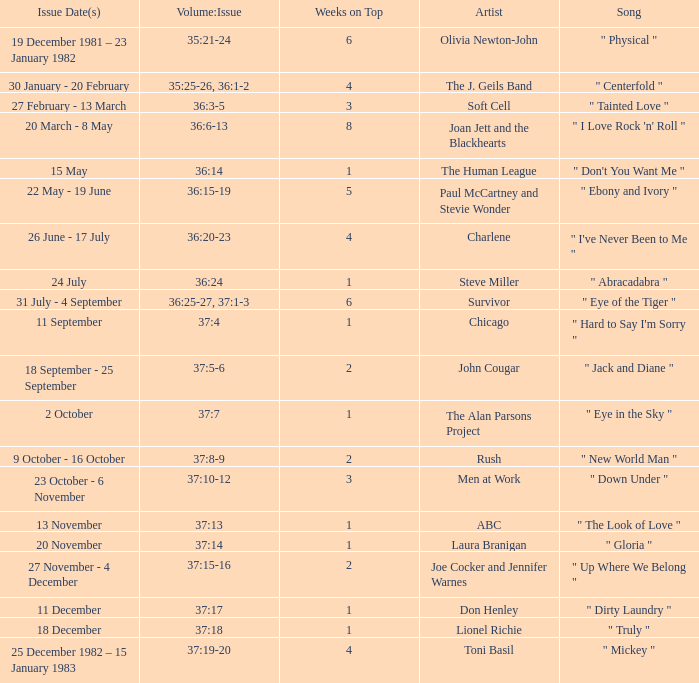Which Weeks on Top have an Issue Date(s) of 20 november? 1.0. 